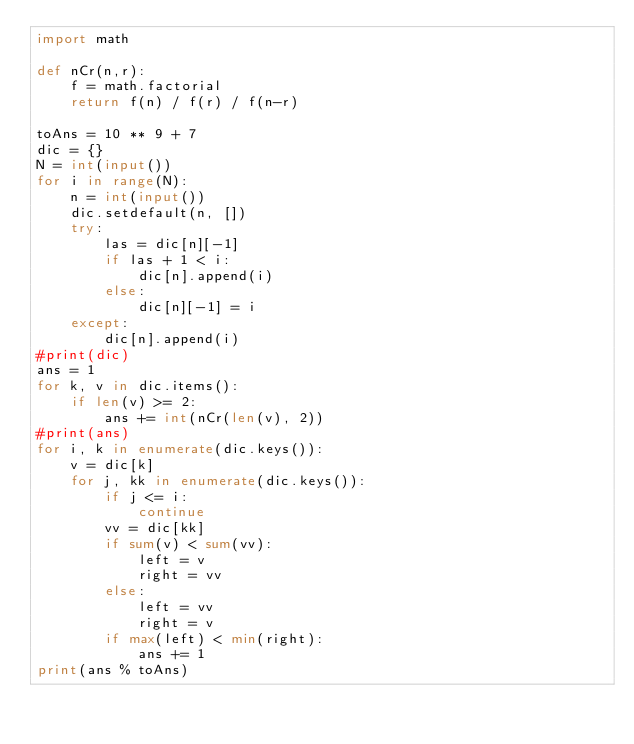Convert code to text. <code><loc_0><loc_0><loc_500><loc_500><_Python_>import math

def nCr(n,r):
    f = math.factorial
    return f(n) / f(r) / f(n-r)

toAns = 10 ** 9 + 7
dic = {}
N = int(input())
for i in range(N):
    n = int(input())
    dic.setdefault(n, [])
    try:
        las = dic[n][-1]
        if las + 1 < i:
            dic[n].append(i)
        else:
            dic[n][-1] = i
    except:
        dic[n].append(i)
#print(dic)
ans = 1
for k, v in dic.items():
    if len(v) >= 2:
        ans += int(nCr(len(v), 2))
#print(ans)
for i, k in enumerate(dic.keys()):
    v = dic[k]
    for j, kk in enumerate(dic.keys()):
        if j <= i:
            continue
        vv = dic[kk]
        if sum(v) < sum(vv):
            left = v
            right = vv
        else:
            left = vv
            right = v
        if max(left) < min(right):
            ans += 1
print(ans % toAns)
</code> 